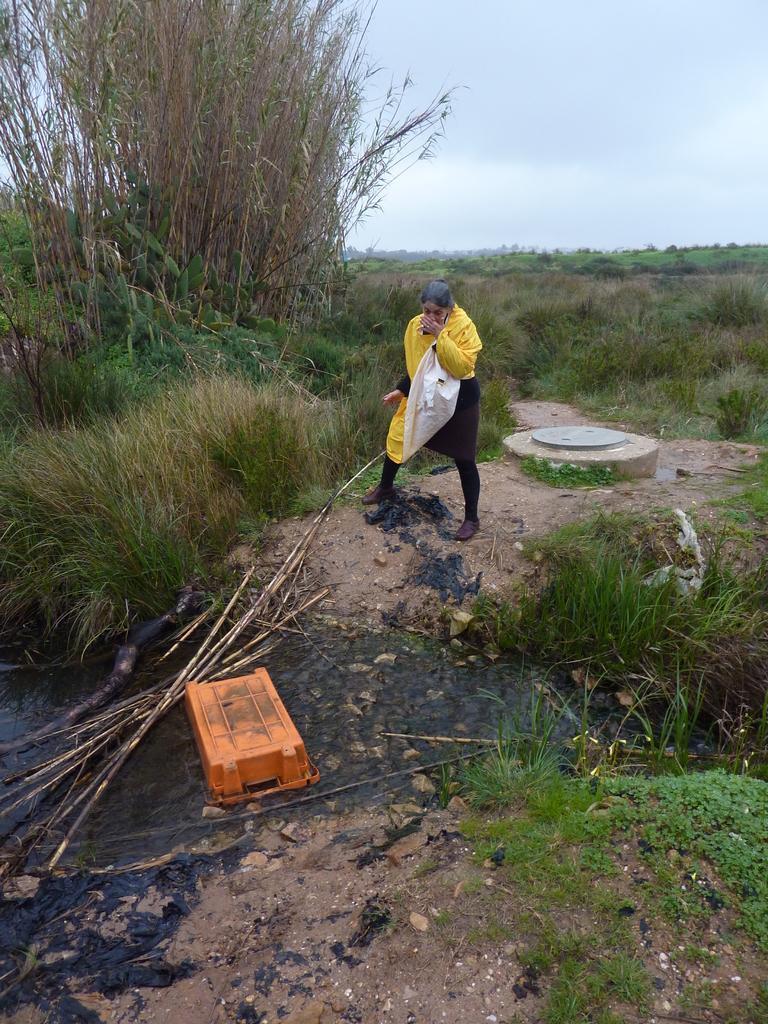In one or two sentences, can you explain what this image depicts? This picture is taken from outside of the city. In this image, in the middle, we can see a person standing on the land. On the right side, we can see some plants and trees. On the left side, we can also see some trees and plants. At the top, we can see a sky which is cloudy, at the bottom, we can see a grass, basket and some wood sticks. 